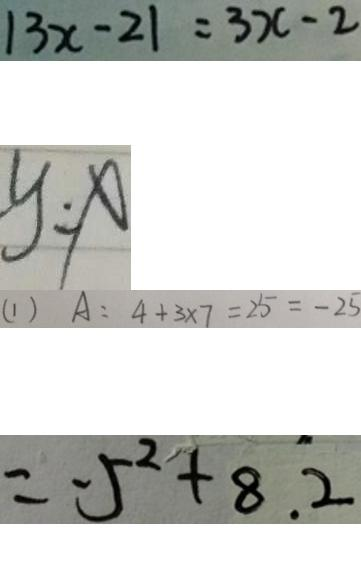<formula> <loc_0><loc_0><loc_500><loc_500>\vert 3 x - 2 \vert = 3 x - 2 
 y = x 
 ( 1 ) A = 4 + 3 \times 7 = 2 5 = - 2 5 
 = - 5 ^ { 2 } + 8 . 2</formula> 